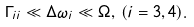Convert formula to latex. <formula><loc_0><loc_0><loc_500><loc_500>\Gamma _ { i i } \ll \Delta \omega _ { i } \ll \Omega , \, ( i = 3 , 4 ) .</formula> 